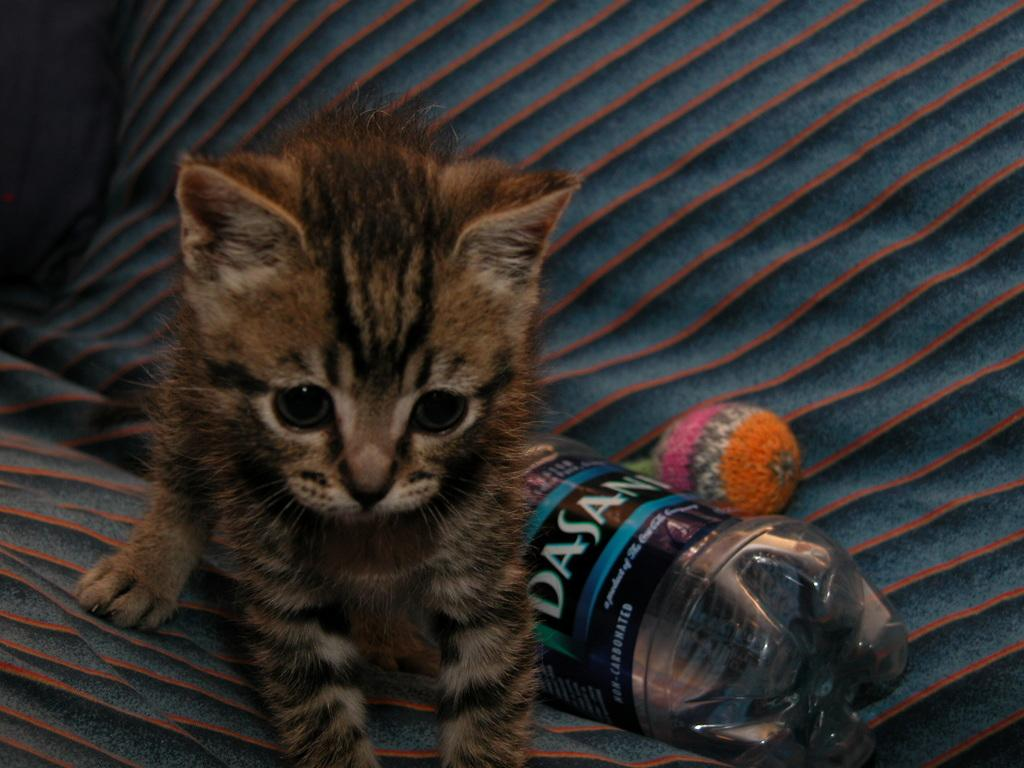What type of animal is in the image? There is a cat in the image. What object is located beside the cat? There is a bottle beside the cat. What type of copper material is present in the image? There is no copper material present in the image. How does the porter interact with the cat in the image? There is no porter present in the image, so there is no interaction with the cat. 